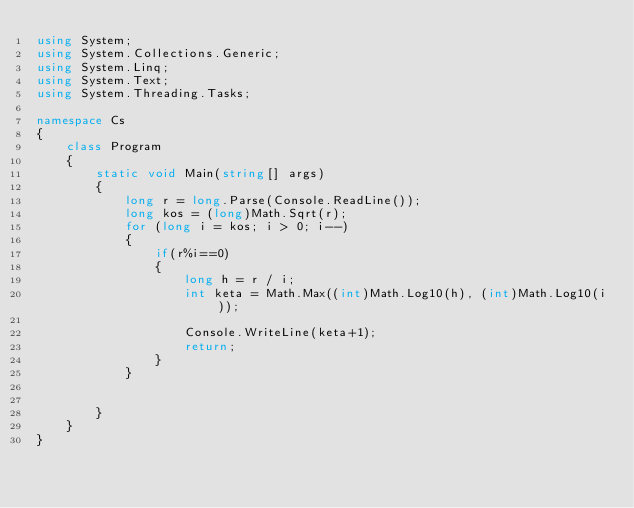<code> <loc_0><loc_0><loc_500><loc_500><_C#_>using System;
using System.Collections.Generic;
using System.Linq;
using System.Text;
using System.Threading.Tasks;

namespace Cs
{
    class Program
    {
        static void Main(string[] args)
        {
            long r = long.Parse(Console.ReadLine());
            long kos = (long)Math.Sqrt(r);
            for (long i = kos; i > 0; i--)
            {
                if(r%i==0)
                {
                    long h = r / i;
                    int keta = Math.Max((int)Math.Log10(h), (int)Math.Log10(i));

                    Console.WriteLine(keta+1);
                    return;
                }
            }


        }
    }
}
</code> 